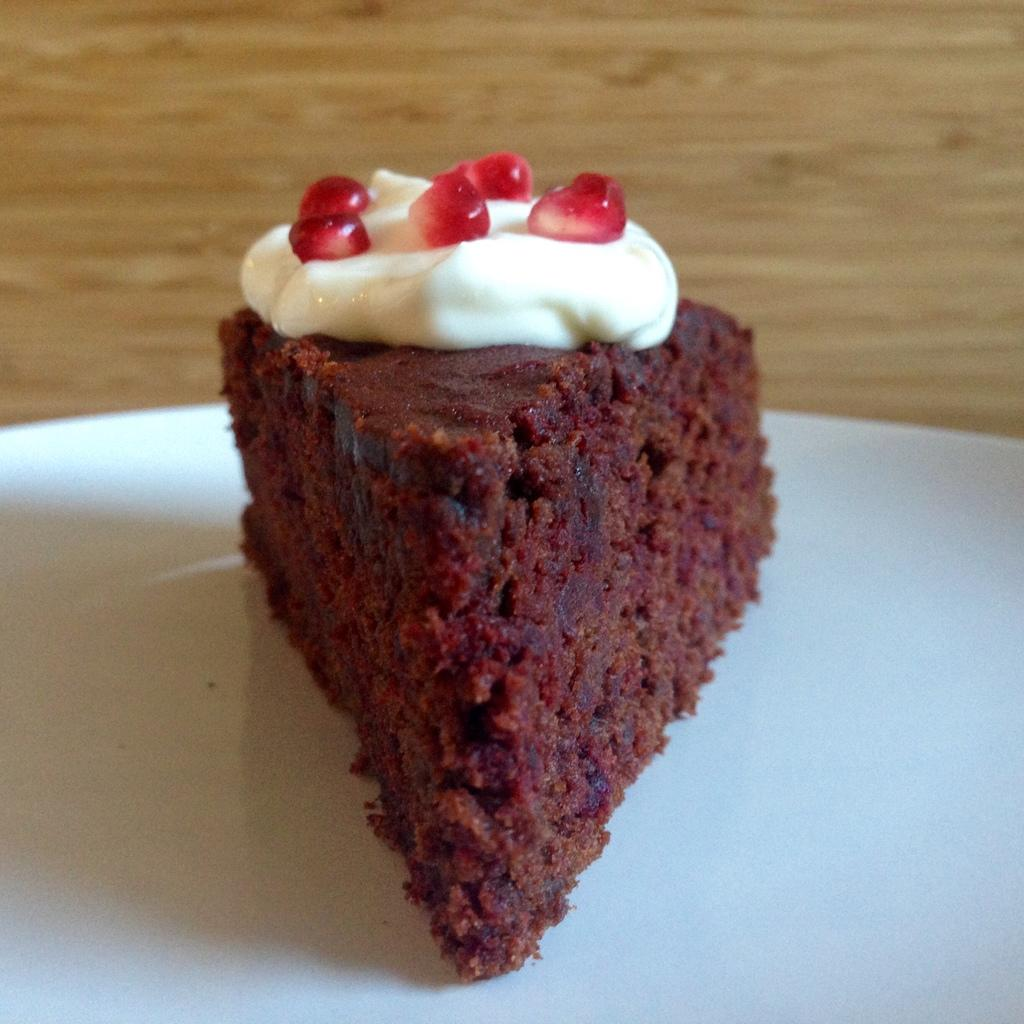What is the main subject of the image? There is a cake on a plate in the image. Can you describe the cake in the image? The cake is on a plate, but no specific details about its appearance or flavor are provided. Is there anything else visible in the image besides the cake? The provided facts do not mention any other objects or subjects in the image. What is the governor's opinion on the cake fight in the image? There is no governor present in the image, nor is there any indication of a cake fight. 